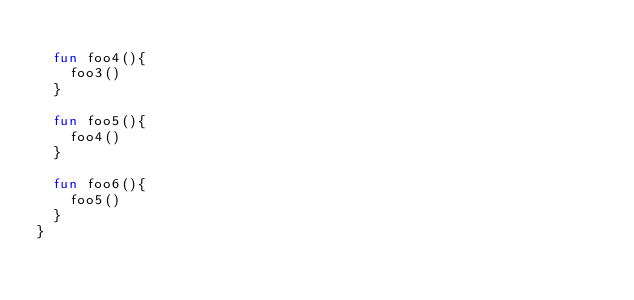<code> <loc_0><loc_0><loc_500><loc_500><_Kotlin_>
  fun foo4(){
    foo3()
  }

  fun foo5(){
    foo4()
  }

  fun foo6(){
    foo5()
  }
}</code> 